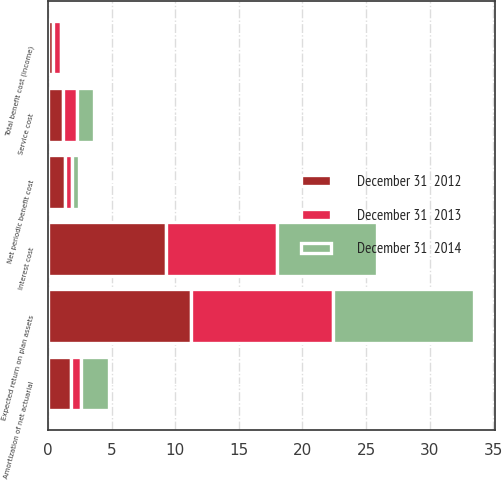Convert chart to OTSL. <chart><loc_0><loc_0><loc_500><loc_500><stacked_bar_chart><ecel><fcel>Service cost<fcel>Interest cost<fcel>Expected return on plan assets<fcel>Amortization of net actuarial<fcel>Net periodic benefit cost<fcel>Total benefit cost (income)<nl><fcel>December 31  2013<fcel>1.1<fcel>8.7<fcel>11.2<fcel>0.8<fcel>0.6<fcel>0.6<nl><fcel>December 31  2014<fcel>1.3<fcel>7.9<fcel>11.1<fcel>2.2<fcel>0.5<fcel>0.2<nl><fcel>December 31  2012<fcel>1.2<fcel>9.3<fcel>11.2<fcel>1.8<fcel>1.3<fcel>0.4<nl></chart> 